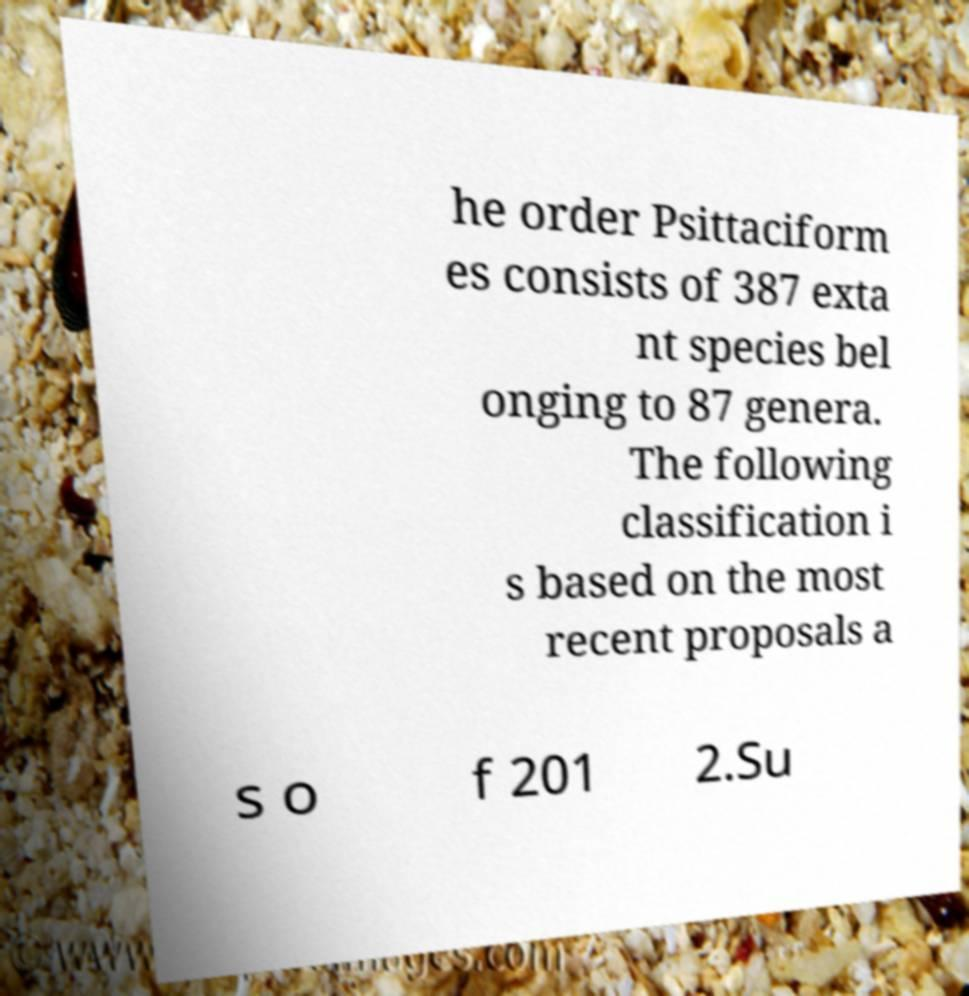For documentation purposes, I need the text within this image transcribed. Could you provide that? he order Psittaciform es consists of 387 exta nt species bel onging to 87 genera. The following classification i s based on the most recent proposals a s o f 201 2.Su 